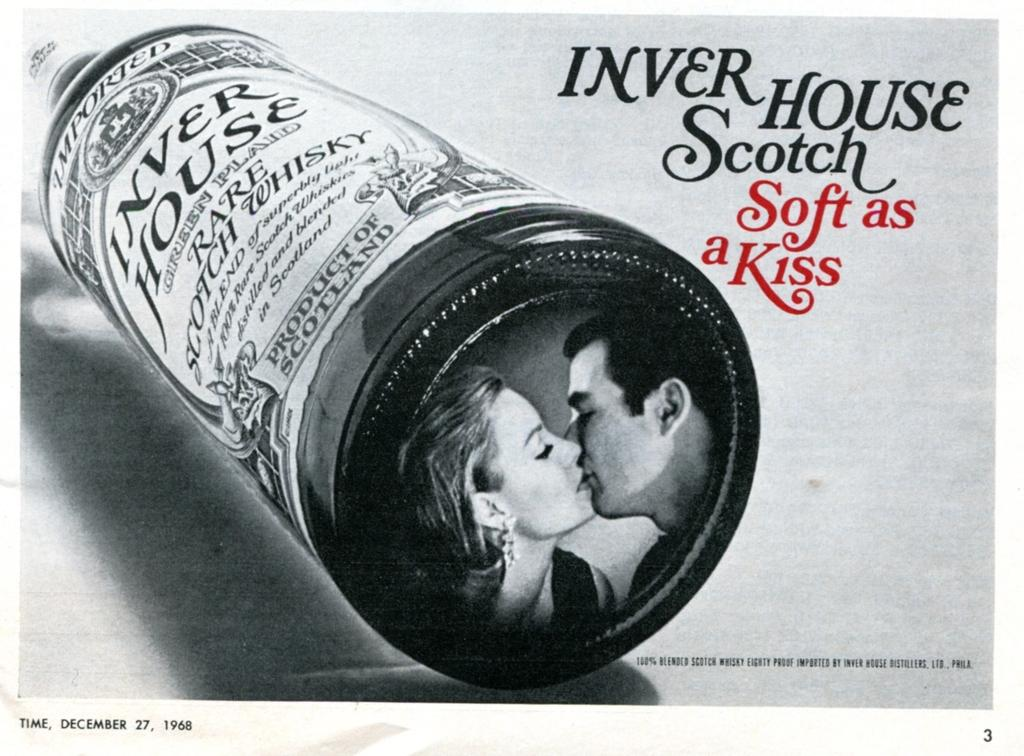What is the color scheme of the image? The image is black and white. What object can be seen on a table in the image? There is a bottle on a table in the image. What features are present on the bottle? The bottle has text and a picture on it. Where can text be found in the image? There is text in the top right corner of the image and at the bottom of the image. Can you hear the fowl crying in the image? There is no fowl or crying sound present in the image, as it is a black and white image featuring a bottle on a table with text and a picture. 